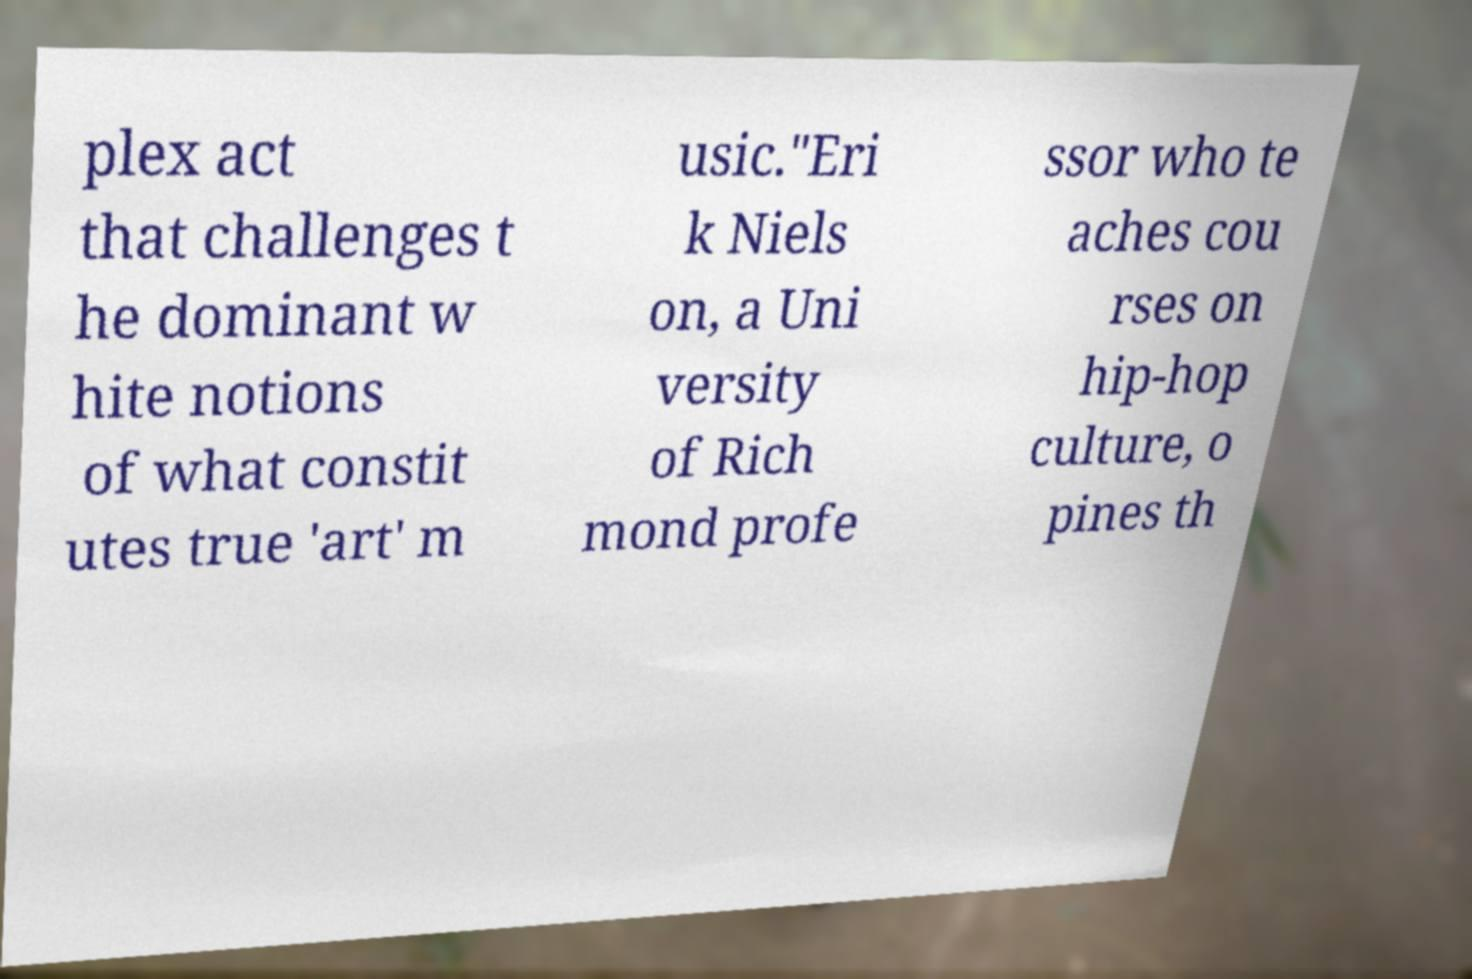Could you assist in decoding the text presented in this image and type it out clearly? plex act that challenges t he dominant w hite notions of what constit utes true 'art' m usic."Eri k Niels on, a Uni versity of Rich mond profe ssor who te aches cou rses on hip-hop culture, o pines th 